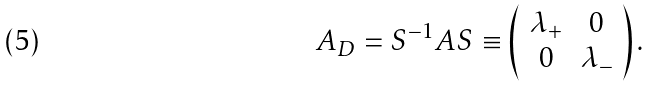Convert formula to latex. <formula><loc_0><loc_0><loc_500><loc_500>A _ { D } = S ^ { - 1 } A S \equiv \left ( \begin{array} { c c } \lambda _ { + } & 0 \\ 0 & \lambda _ { - } \end{array} \right ) .</formula> 